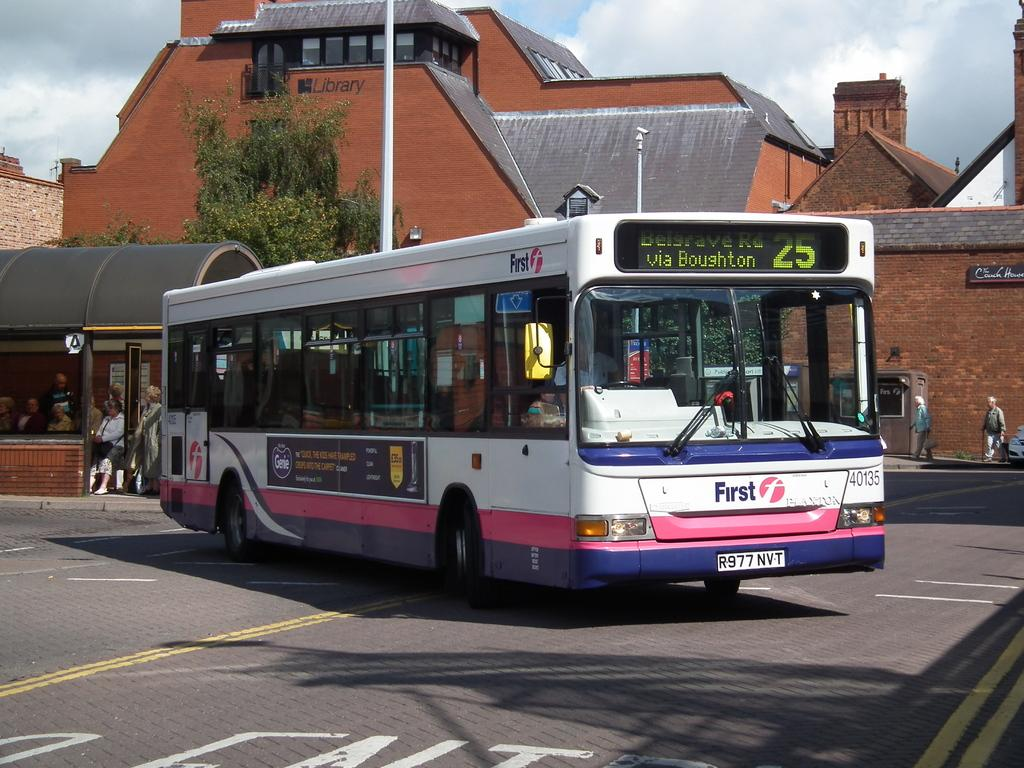<image>
Render a clear and concise summary of the photo. City transit white bus with purple lettering First 